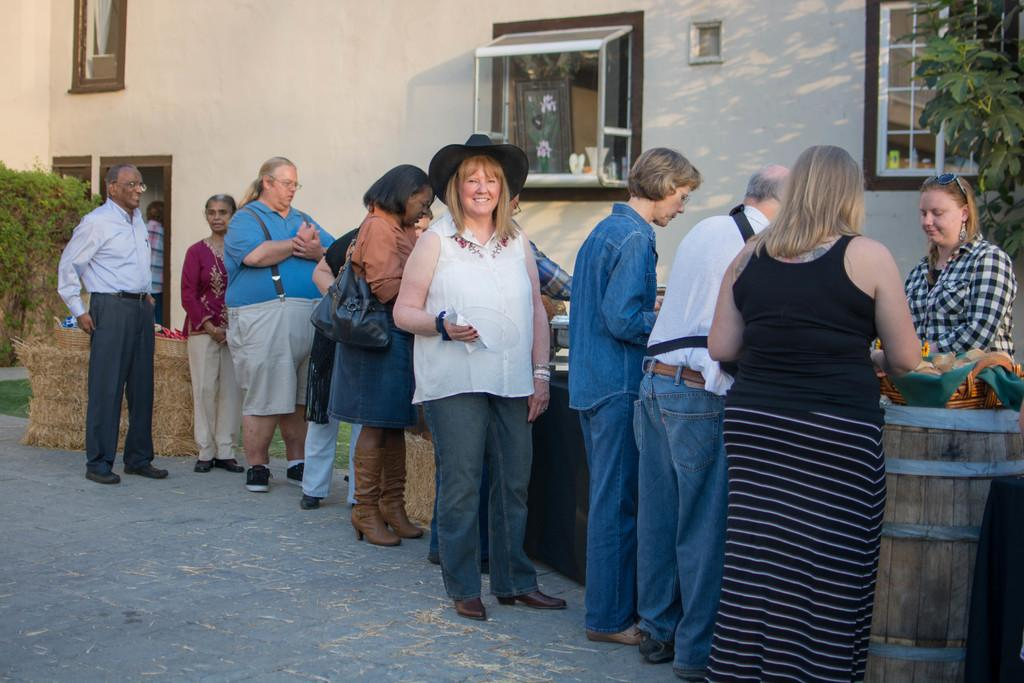How many people can be seen in the image? There are many persons standing on the ground in the image. What objects can be seen on the right side of the image? There is a barrel and a tree on the right side of the image. What can be seen in the background of the image? There is a building and windows visible in the background of the image. Can you see any waves in the image? There are no waves present in the image. Is there any payment being made in the image? There is no indication of any payment being made in the image. 